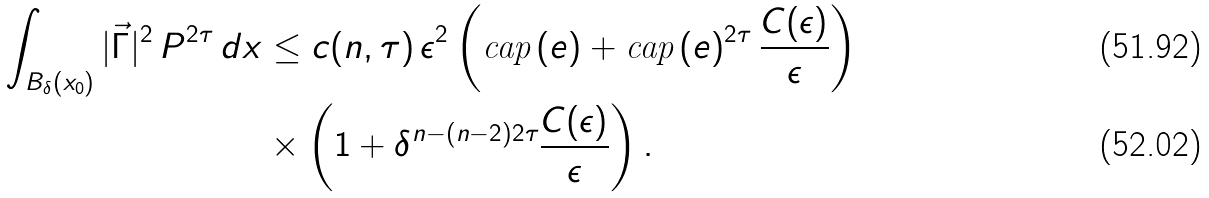<formula> <loc_0><loc_0><loc_500><loc_500>\int _ { B _ { \delta } ( x _ { 0 } ) } | \vec { \Gamma } | ^ { 2 } \, P ^ { 2 \tau } \, d x & \leq c ( n , \tau ) \, \epsilon ^ { 2 } \left ( \text {cap} \, ( e ) + \text {cap} \, ( e ) ^ { 2 \tau } \, \frac { C ( \epsilon ) } { \epsilon } \right ) \\ & \times \left ( 1 + \delta ^ { n - ( n - 2 ) 2 \tau } \frac { C ( \epsilon ) } { \epsilon } \right ) .</formula> 